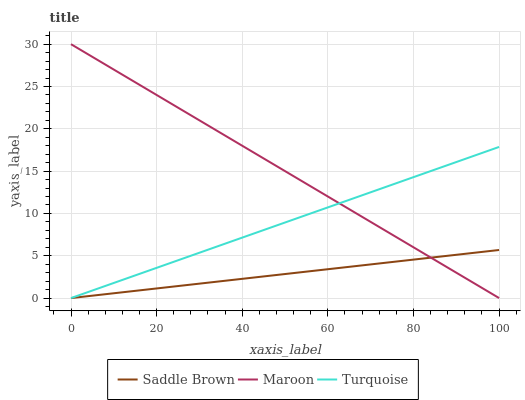Does Saddle Brown have the minimum area under the curve?
Answer yes or no. Yes. Does Maroon have the maximum area under the curve?
Answer yes or no. Yes. Does Maroon have the minimum area under the curve?
Answer yes or no. No. Does Saddle Brown have the maximum area under the curve?
Answer yes or no. No. Is Saddle Brown the smoothest?
Answer yes or no. Yes. Is Maroon the roughest?
Answer yes or no. Yes. Is Maroon the smoothest?
Answer yes or no. No. Is Saddle Brown the roughest?
Answer yes or no. No. Does Turquoise have the lowest value?
Answer yes or no. Yes. Does Maroon have the lowest value?
Answer yes or no. No. Does Maroon have the highest value?
Answer yes or no. Yes. Does Saddle Brown have the highest value?
Answer yes or no. No. Does Maroon intersect Turquoise?
Answer yes or no. Yes. Is Maroon less than Turquoise?
Answer yes or no. No. Is Maroon greater than Turquoise?
Answer yes or no. No. 